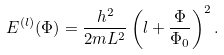<formula> <loc_0><loc_0><loc_500><loc_500>E ^ { ( l ) } ( \Phi ) = \frac { h ^ { 2 } } { 2 m L ^ { 2 } } \left ( l + \frac { \Phi } { \Phi _ { 0 } } \right ) ^ { 2 } .</formula> 